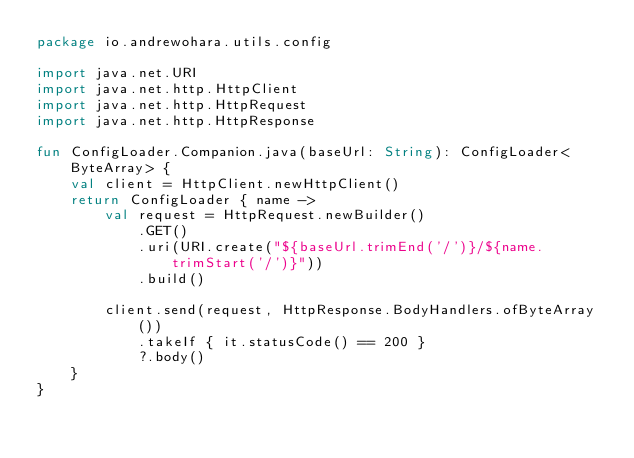Convert code to text. <code><loc_0><loc_0><loc_500><loc_500><_Kotlin_>package io.andrewohara.utils.config

import java.net.URI
import java.net.http.HttpClient
import java.net.http.HttpRequest
import java.net.http.HttpResponse

fun ConfigLoader.Companion.java(baseUrl: String): ConfigLoader<ByteArray> {
    val client = HttpClient.newHttpClient()
    return ConfigLoader { name ->
        val request = HttpRequest.newBuilder()
            .GET()
            .uri(URI.create("${baseUrl.trimEnd('/')}/${name.trimStart('/')}"))
            .build()

        client.send(request, HttpResponse.BodyHandlers.ofByteArray())
            .takeIf { it.statusCode() == 200 }
            ?.body()
    }
}</code> 